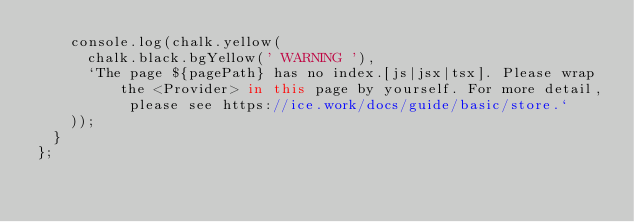<code> <loc_0><loc_0><loc_500><loc_500><_TypeScript_>    console.log(chalk.yellow(
      chalk.black.bgYellow(' WARNING '),
      `The page ${pagePath} has no index.[js|jsx|tsx]. Please wrap the <Provider> in this page by yourself. For more detail, please see https://ice.work/docs/guide/basic/store.`
    ));
  }
};
</code> 